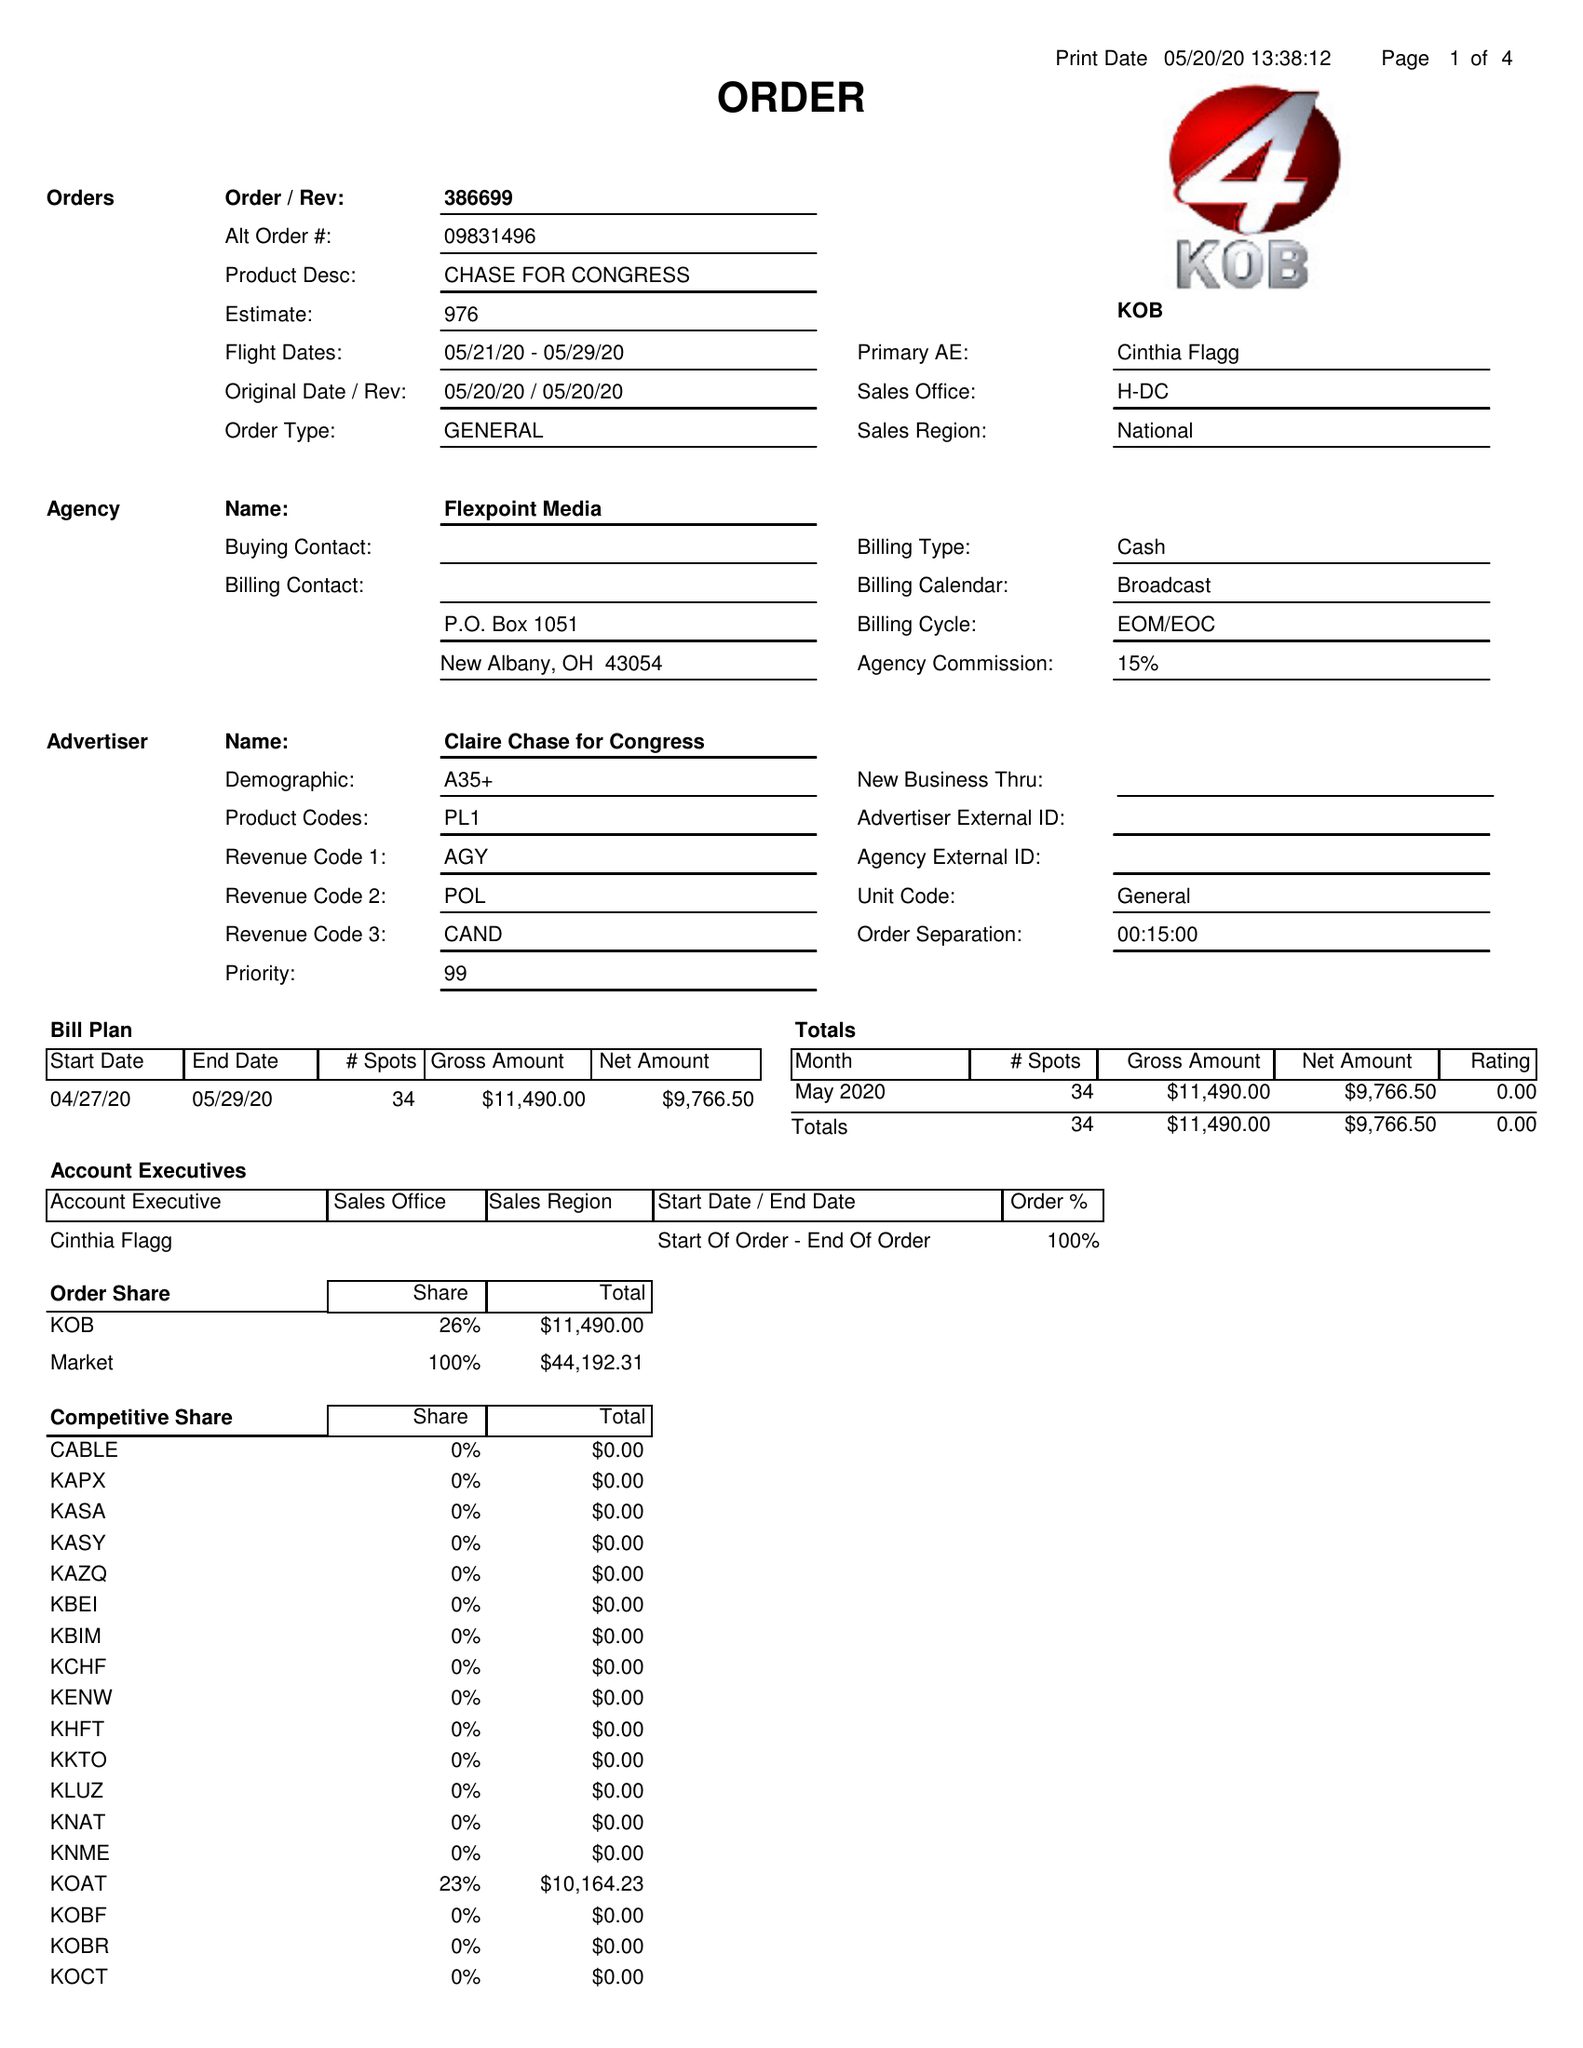What is the value for the flight_to?
Answer the question using a single word or phrase. 05/29/20 